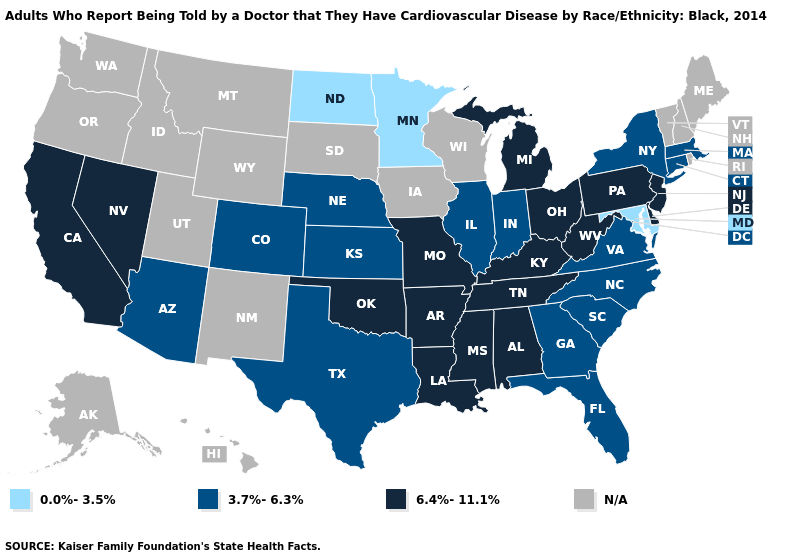Among the states that border Pennsylvania , does West Virginia have the highest value?
Give a very brief answer. Yes. Among the states that border South Carolina , which have the lowest value?
Concise answer only. Georgia, North Carolina. What is the value of Idaho?
Keep it brief. N/A. What is the value of New Hampshire?
Keep it brief. N/A. Name the states that have a value in the range 3.7%-6.3%?
Give a very brief answer. Arizona, Colorado, Connecticut, Florida, Georgia, Illinois, Indiana, Kansas, Massachusetts, Nebraska, New York, North Carolina, South Carolina, Texas, Virginia. Name the states that have a value in the range N/A?
Concise answer only. Alaska, Hawaii, Idaho, Iowa, Maine, Montana, New Hampshire, New Mexico, Oregon, Rhode Island, South Dakota, Utah, Vermont, Washington, Wisconsin, Wyoming. What is the value of South Carolina?
Concise answer only. 3.7%-6.3%. Does Colorado have the highest value in the West?
Quick response, please. No. What is the lowest value in the Northeast?
Keep it brief. 3.7%-6.3%. Which states have the lowest value in the USA?
Quick response, please. Maryland, Minnesota, North Dakota. What is the value of Ohio?
Keep it brief. 6.4%-11.1%. What is the value of Maine?
Short answer required. N/A. 